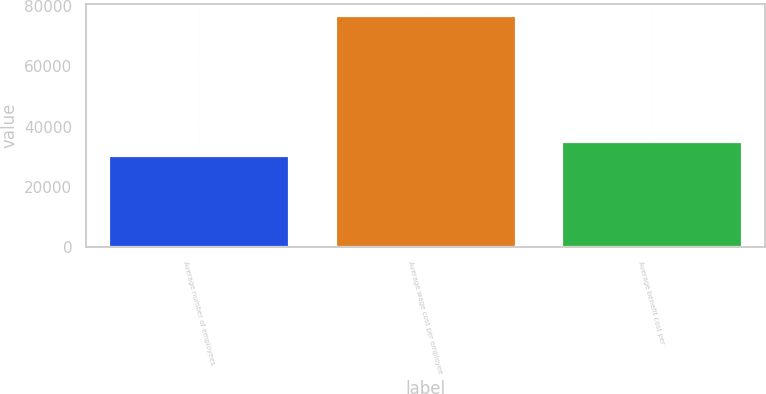Convert chart to OTSL. <chart><loc_0><loc_0><loc_500><loc_500><bar_chart><fcel>Average number of employees<fcel>Average wage cost per employee<fcel>Average benefit cost per<nl><fcel>30456<fcel>77000<fcel>35110.4<nl></chart> 